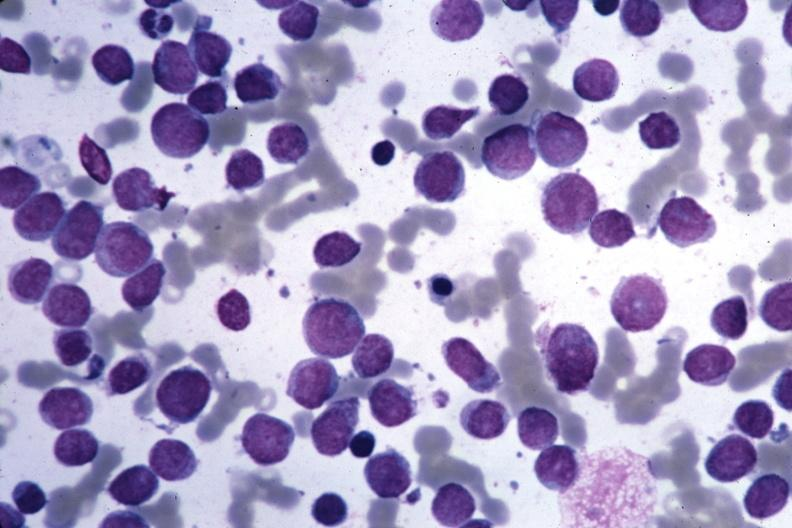s acute myelogenous leukemia present?
Answer the question using a single word or phrase. Yes 